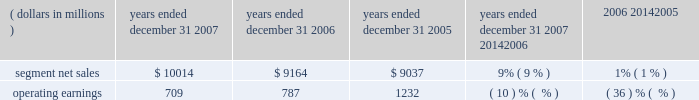Unit shipments increased 49% ( 49 % ) to 217.4 million units in 2006 , compared to 146.0 million units in 2005 .
The overall increase was driven by increased unit shipments of products for gsm , cdma and 3g technologies , partially offset by decreased unit shipments of products for iden technology .
For the full year 2006 , unit shipments by the segment increased in all regions .
Due to the segment 2019s increase in unit shipments outpacing overall growth in the worldwide handset market , which grew approximately 20% ( 20 % ) in 2006 , the segment believes that it expanded its global handset market share to an estimated 22% ( 22 % ) for the full year 2006 .
In 2006 , asp decreased approximately 11% ( 11 % ) compared to 2005 .
The overall decrease in asp was driven primarily by changes in the geographic and product-tier mix of sales .
By comparison , asp decreased approximately 10% ( 10 % ) in 2005 and increased approximately 15% ( 15 % ) in 2004 .
Asp is impacted by numerous factors , including product mix , market conditions and competitive product offerings , and asp trends often vary over time .
In 2006 , the largest of the segment 2019s end customers ( including sales through distributors ) were china mobile , verizon , sprint nextel , cingular , and t-mobile .
These five largest customers accounted for approximately 39% ( 39 % ) of the segment 2019s net sales in 2006 .
Besides selling directly to carriers and operators , the segment also sold products through a variety of third-party distributors and retailers , which accounted for approximately 38% ( 38 % ) of the segment 2019s net sales .
The largest of these distributors was brightstar corporation .
Although the u.s .
Market continued to be the segment 2019s largest individual market , many of our customers , and more than 65% ( 65 % ) of the segment 2019s 2006 net sales , were outside the u.s .
The largest of these international markets were china , brazil , the united kingdom and mexico .
Home and networks mobility segment the home and networks mobility segment designs , manufactures , sells , installs and services : ( i ) digital video , internet protocol ( 201cip 201d ) video and broadcast network interactive set-tops ( 201cdigital entertainment devices 201d ) , end-to- end video delivery solutions , broadband access infrastructure systems , and associated data and voice customer premise equipment ( 201cbroadband gateways 201d ) to cable television and telecom service providers ( collectively , referred to as the 201chome business 201d ) , and ( ii ) wireless access systems ( 201cwireless networks 201d ) , including cellular infrastructure systems and wireless broadband systems , to wireless service providers .
In 2007 , the segment 2019s net sales represented 27% ( 27 % ) of the company 2019s consolidated net sales , compared to 21% ( 21 % ) in 2006 and 26% ( 26 % ) in 2005 .
( dollars in millions ) 2007 2006 2005 2007 20142006 2006 20142005 years ended december 31 percent change .
Segment results 20142007 compared to 2006 in 2007 , the segment 2019s net sales increased 9% ( 9 % ) to $ 10.0 billion , compared to $ 9.2 billion in 2006 .
The 9% ( 9 % ) increase in net sales reflects a 27% ( 27 % ) increase in net sales in the home business , partially offset by a 1% ( 1 % ) decrease in net sales of wireless networks .
Net sales of digital entertainment devices increased approximately 43% ( 43 % ) , reflecting increased demand for digital set-tops , including hd/dvr set-tops and ip set-tops , partially offset by a decline in asp due to a product mix shift towards all-digital set-tops .
Unit shipments of digital entertainment devices increased 51% ( 51 % ) to 15.2 million units .
Net sales of broadband gateways increased approximately 6% ( 6 % ) , primarily due to higher net sales of data modems , driven by net sales from the netopia business acquired in february 2007 .
Net sales of wireless networks decreased 1% ( 1 % ) , primarily driven by lower net sales of iden and cdma infrastructure equipment , partially offset by higher net sales of gsm infrastructure equipment , despite competitive pricing pressure .
On a geographic basis , the 9% ( 9 % ) increase in net sales reflects higher net sales in all geographic regions .
The increase in net sales in north america was driven primarily by higher sales of digital entertainment devices , partially offset by lower net sales of iden and cdma infrastructure equipment .
The increase in net sales in asia was primarily due to higher net sales of gsm infrastructure equipment , partially offset by lower net sales of cdma infrastructure equipment .
The increase in net sales in emea was , primarily due to higher net sales of gsm infrastructure equipment , partially offset by lower demand for iden and cdma infrastructure equipment .
Net sales in north america continue to comprise a significant portion of the segment 2019s business , accounting for 52% ( 52 % ) of the segment 2019s total net sales in 2007 , compared to 56% ( 56 % ) of the segment 2019s total net sales in 2006 .
60 management 2019s discussion and analysis of financial condition and results of operations .
What was the growth , in a percentage , of the consolidated net sales from 2005 to 2007? 
Rationale: in line 17 it said the percentage of total segmented sales relative to consolidated net sales . you take this percentage and multiple it by the segmented net sales to get the consolidated net sales . then you must take these two products and subtract them from each other . this product is then divided by the the consolidated net sales in 2005 .
Computations: (((10014 * 27%) - (9037 * 26%)) / (9037 * 26%))
Answer: 0.15073. 